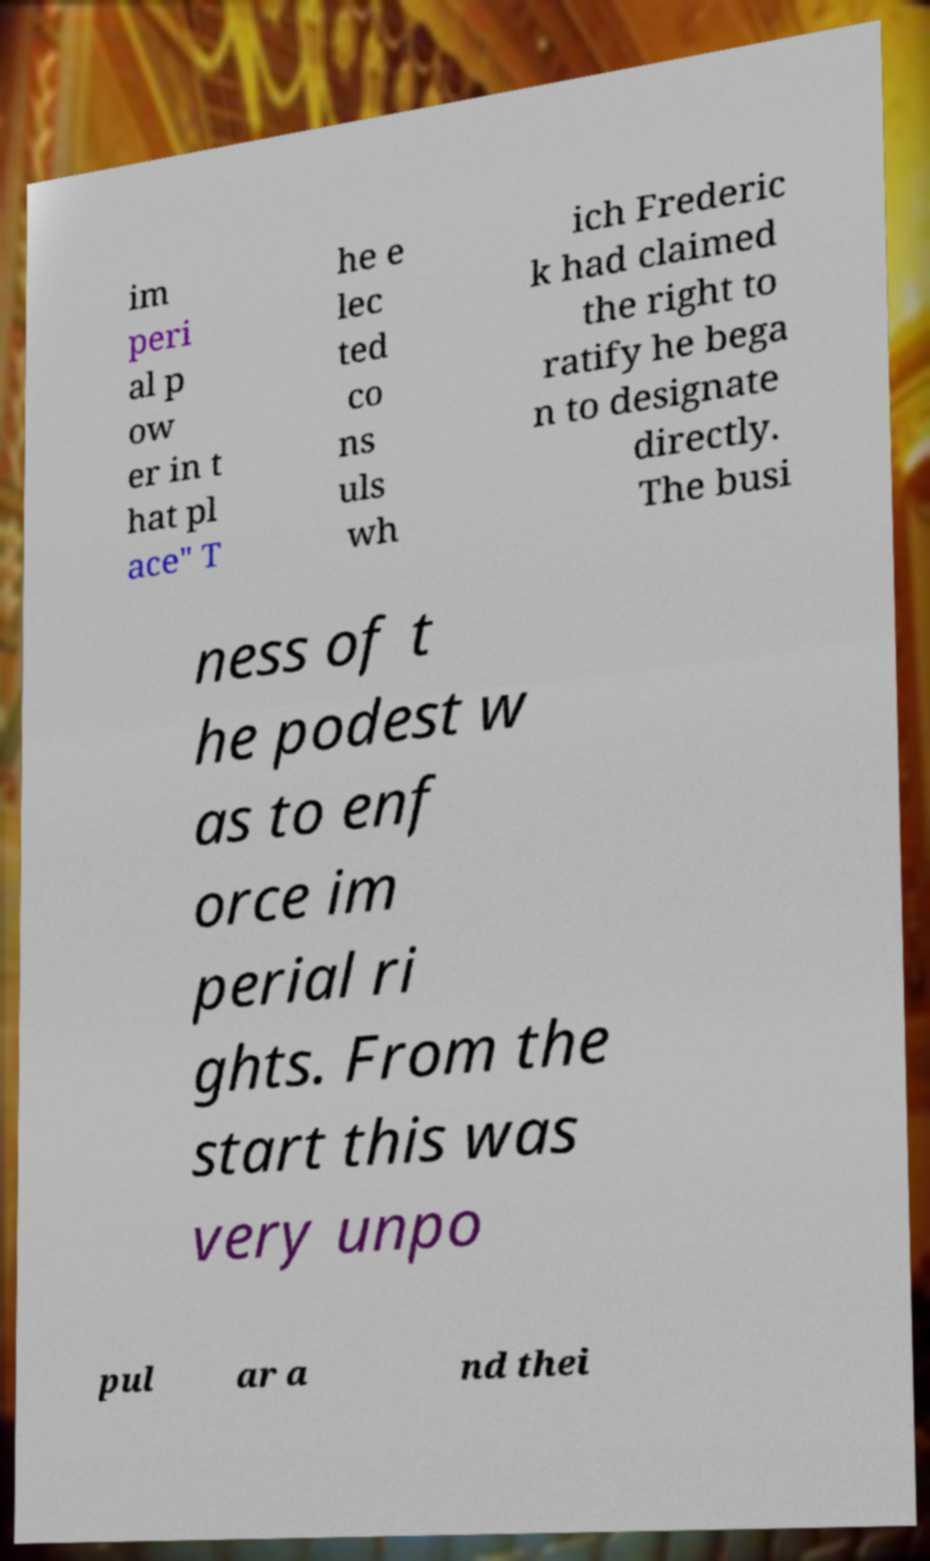For documentation purposes, I need the text within this image transcribed. Could you provide that? im peri al p ow er in t hat pl ace" T he e lec ted co ns uls wh ich Frederic k had claimed the right to ratify he bega n to designate directly. The busi ness of t he podest w as to enf orce im perial ri ghts. From the start this was very unpo pul ar a nd thei 